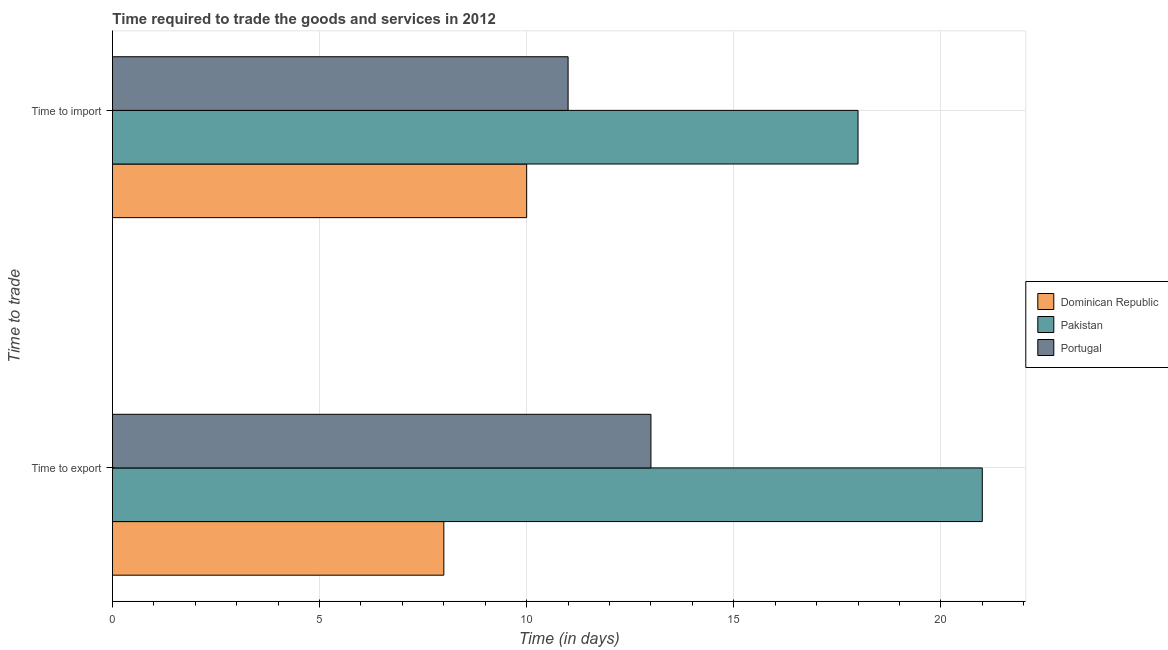How many different coloured bars are there?
Keep it short and to the point. 3. How many groups of bars are there?
Make the answer very short. 2. Are the number of bars per tick equal to the number of legend labels?
Your response must be concise. Yes. How many bars are there on the 2nd tick from the top?
Make the answer very short. 3. What is the label of the 2nd group of bars from the top?
Provide a short and direct response. Time to export. What is the time to import in Dominican Republic?
Give a very brief answer. 10. Across all countries, what is the maximum time to import?
Make the answer very short. 18. Across all countries, what is the minimum time to import?
Ensure brevity in your answer.  10. In which country was the time to import maximum?
Keep it short and to the point. Pakistan. In which country was the time to export minimum?
Give a very brief answer. Dominican Republic. What is the total time to export in the graph?
Your response must be concise. 42. What is the difference between the time to export in Dominican Republic and that in Portugal?
Offer a terse response. -5. What is the difference between the time to export in Portugal and the time to import in Dominican Republic?
Your response must be concise. 3. What is the average time to import per country?
Ensure brevity in your answer.  13. What is the difference between the time to export and time to import in Dominican Republic?
Provide a short and direct response. -2. What is the ratio of the time to import in Pakistan to that in Portugal?
Ensure brevity in your answer.  1.64. In how many countries, is the time to import greater than the average time to import taken over all countries?
Your answer should be compact. 1. What does the 2nd bar from the top in Time to import represents?
Provide a short and direct response. Pakistan. How many bars are there?
Offer a terse response. 6. How many countries are there in the graph?
Provide a succinct answer. 3. Are the values on the major ticks of X-axis written in scientific E-notation?
Your answer should be compact. No. Does the graph contain any zero values?
Your answer should be compact. No. How many legend labels are there?
Your answer should be very brief. 3. What is the title of the graph?
Your response must be concise. Time required to trade the goods and services in 2012. Does "Venezuela" appear as one of the legend labels in the graph?
Ensure brevity in your answer.  No. What is the label or title of the X-axis?
Give a very brief answer. Time (in days). What is the label or title of the Y-axis?
Offer a very short reply. Time to trade. What is the Time (in days) in Dominican Republic in Time to export?
Provide a succinct answer. 8. What is the Time (in days) of Pakistan in Time to export?
Give a very brief answer. 21. What is the Time (in days) in Portugal in Time to export?
Give a very brief answer. 13. What is the Time (in days) in Dominican Republic in Time to import?
Give a very brief answer. 10. What is the Time (in days) of Pakistan in Time to import?
Provide a short and direct response. 18. What is the Time (in days) of Portugal in Time to import?
Offer a terse response. 11. Across all Time to trade, what is the maximum Time (in days) in Dominican Republic?
Keep it short and to the point. 10. Across all Time to trade, what is the maximum Time (in days) of Pakistan?
Give a very brief answer. 21. Across all Time to trade, what is the minimum Time (in days) of Pakistan?
Provide a short and direct response. 18. What is the total Time (in days) in Dominican Republic in the graph?
Your response must be concise. 18. What is the total Time (in days) in Pakistan in the graph?
Give a very brief answer. 39. What is the difference between the Time (in days) in Dominican Republic in Time to export and that in Time to import?
Give a very brief answer. -2. What is the difference between the Time (in days) in Portugal in Time to export and that in Time to import?
Offer a very short reply. 2. What is the average Time (in days) of Pakistan per Time to trade?
Offer a terse response. 19.5. What is the difference between the Time (in days) in Dominican Republic and Time (in days) in Pakistan in Time to export?
Offer a terse response. -13. What is the ratio of the Time (in days) of Pakistan in Time to export to that in Time to import?
Offer a terse response. 1.17. What is the ratio of the Time (in days) in Portugal in Time to export to that in Time to import?
Your response must be concise. 1.18. What is the difference between the highest and the second highest Time (in days) in Dominican Republic?
Your answer should be very brief. 2. What is the difference between the highest and the second highest Time (in days) in Pakistan?
Offer a very short reply. 3. What is the difference between the highest and the second highest Time (in days) of Portugal?
Your answer should be very brief. 2. What is the difference between the highest and the lowest Time (in days) of Dominican Republic?
Your answer should be very brief. 2. What is the difference between the highest and the lowest Time (in days) of Pakistan?
Ensure brevity in your answer.  3. What is the difference between the highest and the lowest Time (in days) of Portugal?
Your response must be concise. 2. 